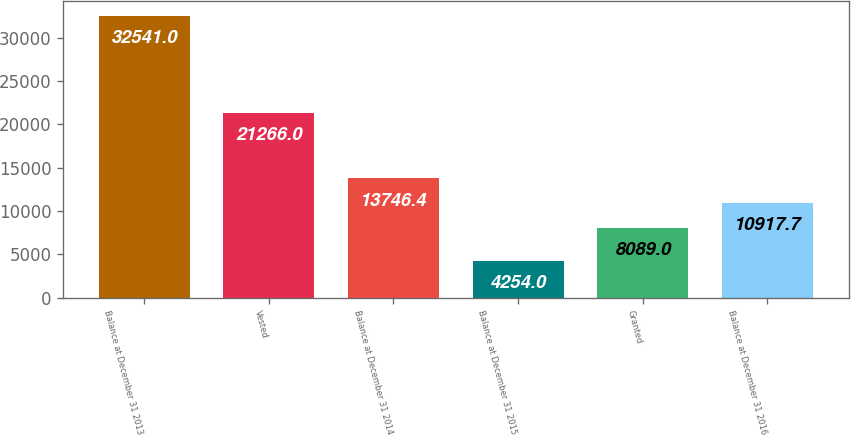Convert chart to OTSL. <chart><loc_0><loc_0><loc_500><loc_500><bar_chart><fcel>Balance at December 31 2013<fcel>Vested<fcel>Balance at December 31 2014<fcel>Balance at December 31 2015<fcel>Granted<fcel>Balance at December 31 2016<nl><fcel>32541<fcel>21266<fcel>13746.4<fcel>4254<fcel>8089<fcel>10917.7<nl></chart> 